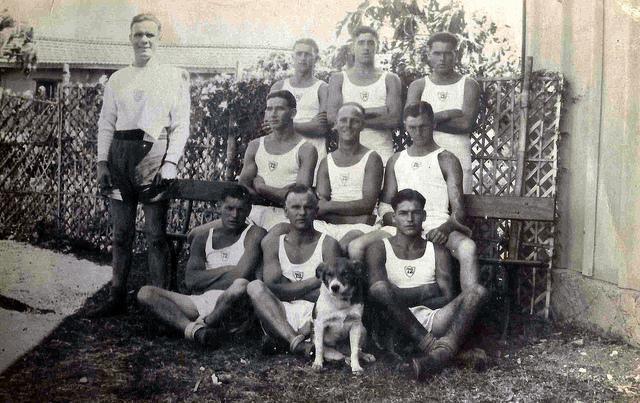What type of tops are the men on the right wearing?
Indicate the correct response and explain using: 'Answer: answer
Rationale: rationale.'
Options: Skinny tops, crop tops, big tops, tank tops. Answer: tank tops.
Rationale: The men are wearing shirts without sleeves. this style of shirt is referred to as answer a. 